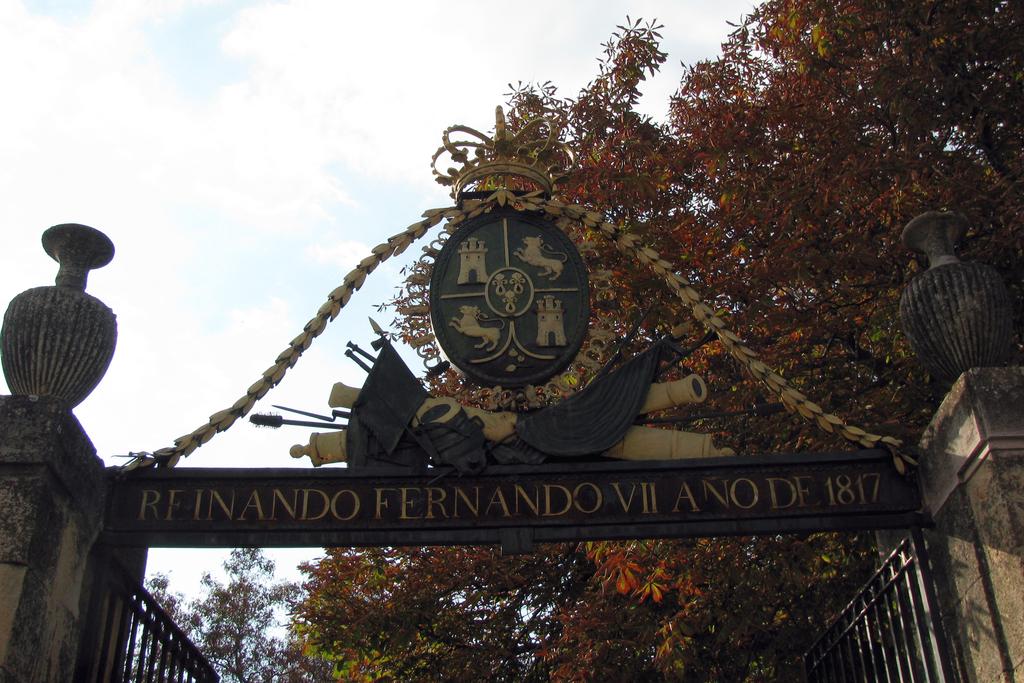When was the estate built, according to the sign?
Your answer should be very brief. 1817. 